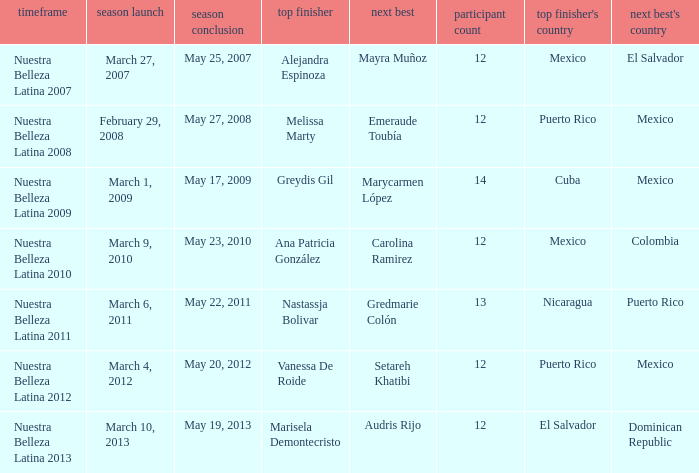What season had more than 12 contestants in which greydis gil won? Nuestra Belleza Latina 2009. 